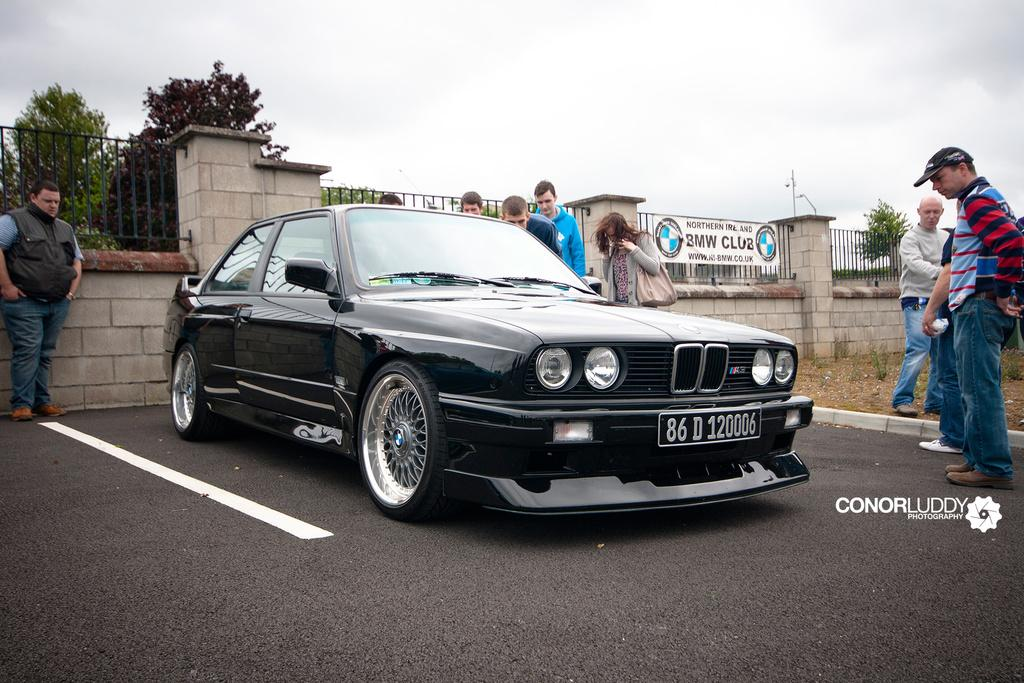What is the main subject of the image? The main subject of the image is a car on the road. What type of fencing can be seen in the image? There is wall top fencing in the image. What additional object is present in the image? There is a banner in the image. What can be seen near the car? There is a bag in the image. What type of vegetation is visible in the image? There are trees in the image. Who is present in the image? There is a group of people standing in the image. What is visible in the background of the image? The sky with clouds is visible in the background of the image. How many women are smiling in the image? There are no women or smiles present in the image. What type of branch is being used by the people in the image? There are no branches present in the image. 